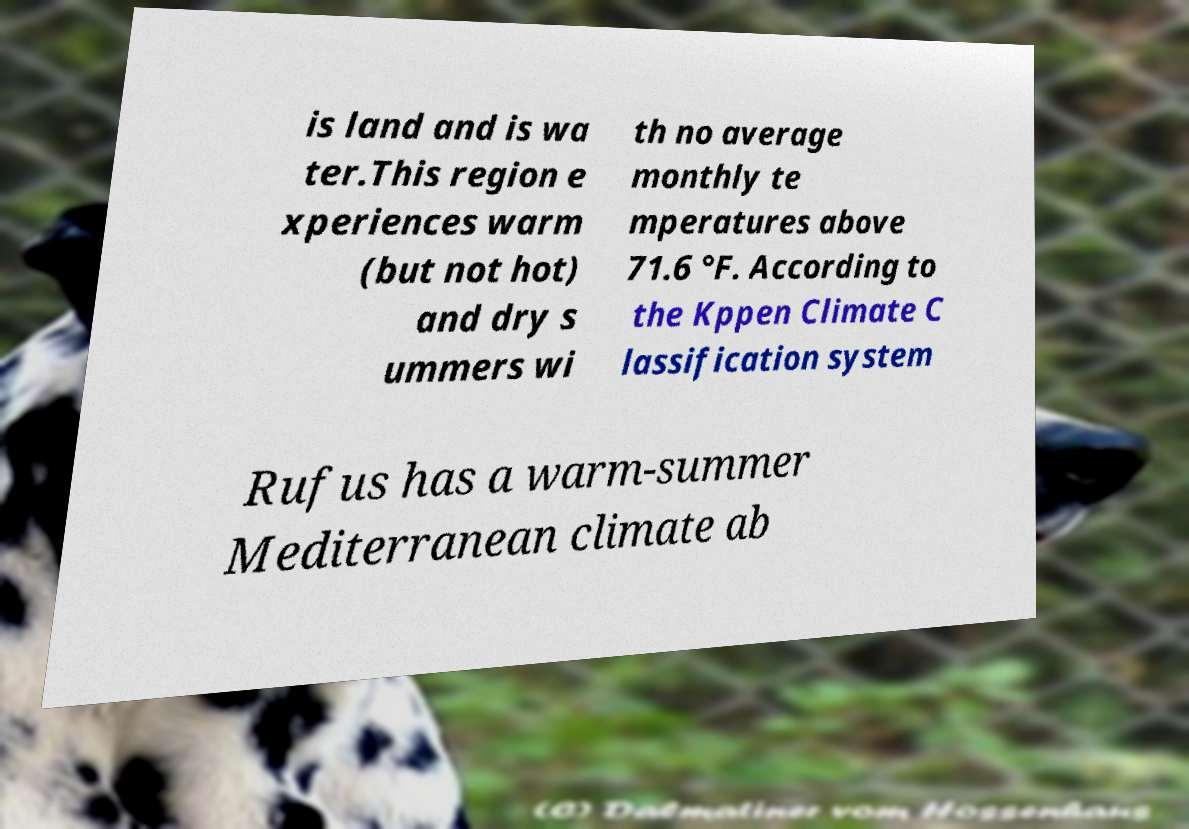Can you accurately transcribe the text from the provided image for me? is land and is wa ter.This region e xperiences warm (but not hot) and dry s ummers wi th no average monthly te mperatures above 71.6 °F. According to the Kppen Climate C lassification system Rufus has a warm-summer Mediterranean climate ab 